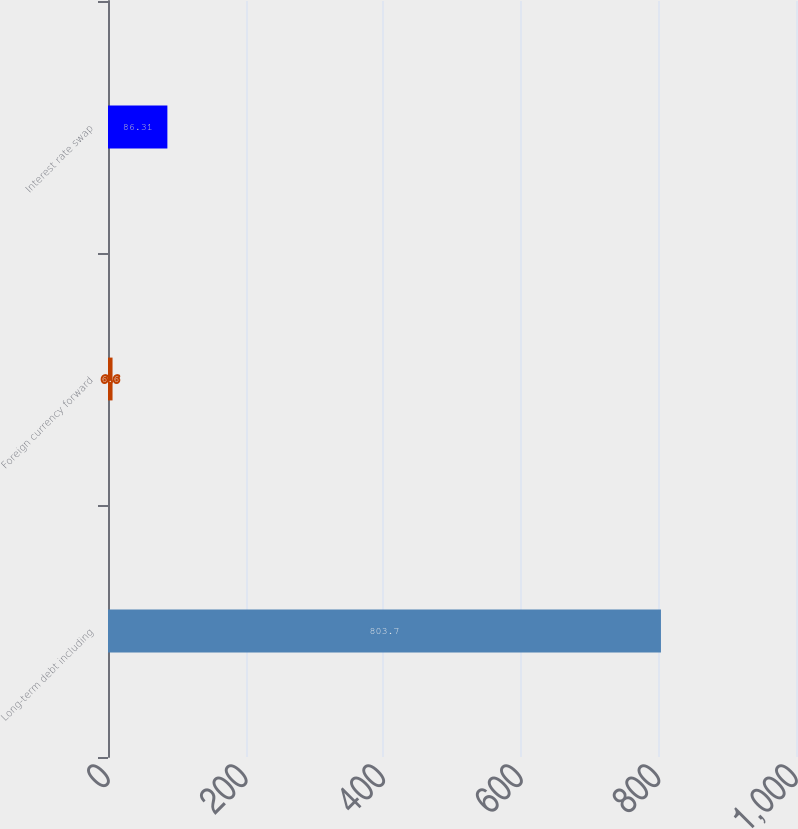Convert chart. <chart><loc_0><loc_0><loc_500><loc_500><bar_chart><fcel>Long-term debt including<fcel>Foreign currency forward<fcel>Interest rate swap<nl><fcel>803.7<fcel>6.6<fcel>86.31<nl></chart> 